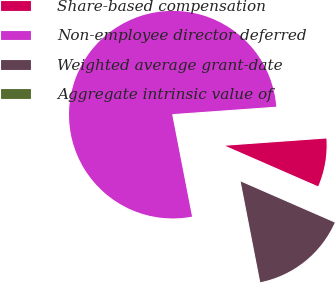Convert chart. <chart><loc_0><loc_0><loc_500><loc_500><pie_chart><fcel>Share-based compensation<fcel>Non-employee director deferred<fcel>Weighted average grant-date<fcel>Aggregate intrinsic value of<nl><fcel>7.69%<fcel>76.92%<fcel>15.39%<fcel>0.0%<nl></chart> 